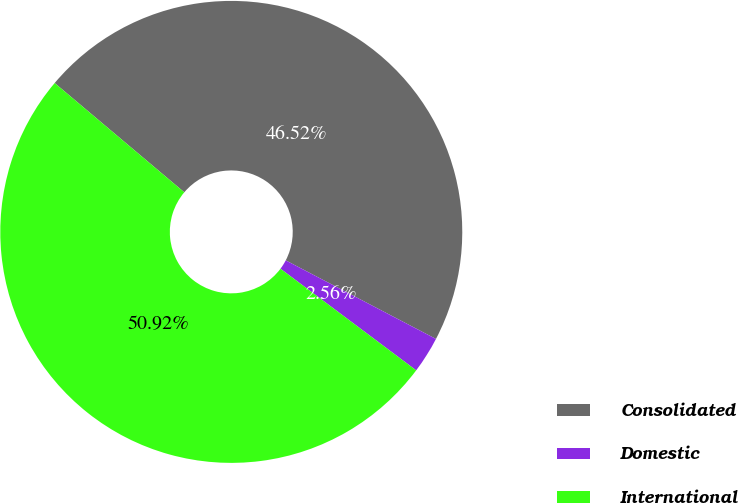Convert chart. <chart><loc_0><loc_0><loc_500><loc_500><pie_chart><fcel>Consolidated<fcel>Domestic<fcel>International<nl><fcel>46.52%<fcel>2.56%<fcel>50.91%<nl></chart> 